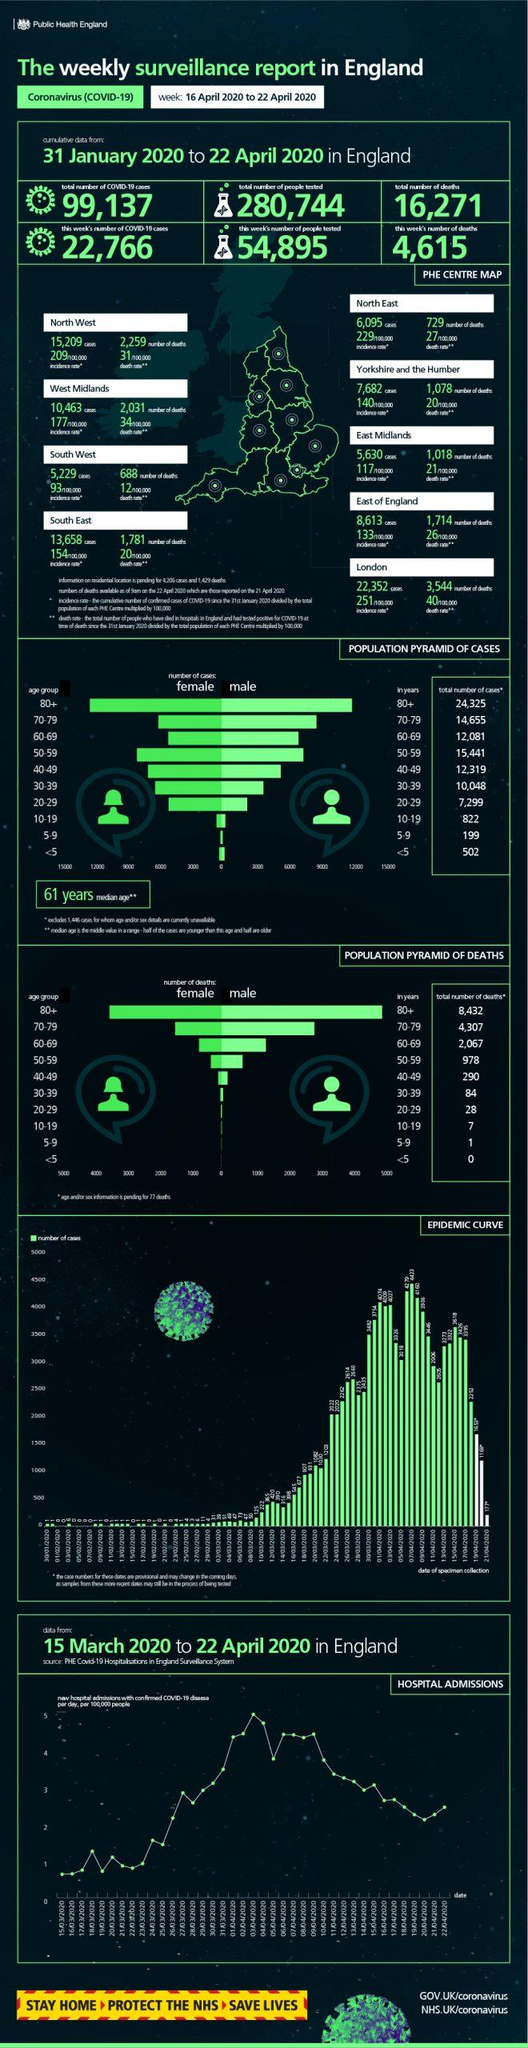Point out several critical features in this image. During the 31 January 2020 - 22 April 2020 period in England, the highest number of COVID-19 cases were reported in the age group of 80 years and older. During the period of 16 April 2020 - 22 April 2020, a total of 4,615 COVID-19 deaths were reported in England. During the period of 31 January 2020 to 22 April 2020 in England, the reported total number of deaths in children aged between 10-19 years was 7. During the period of 31 January 2020 to 22 April 2020 in England, a total of 280,744 people were tested for COVID-19. A total of 8,613 COVID-19 cases were reported in the East of England region from 31 January 2020 to 22 April 2020. 